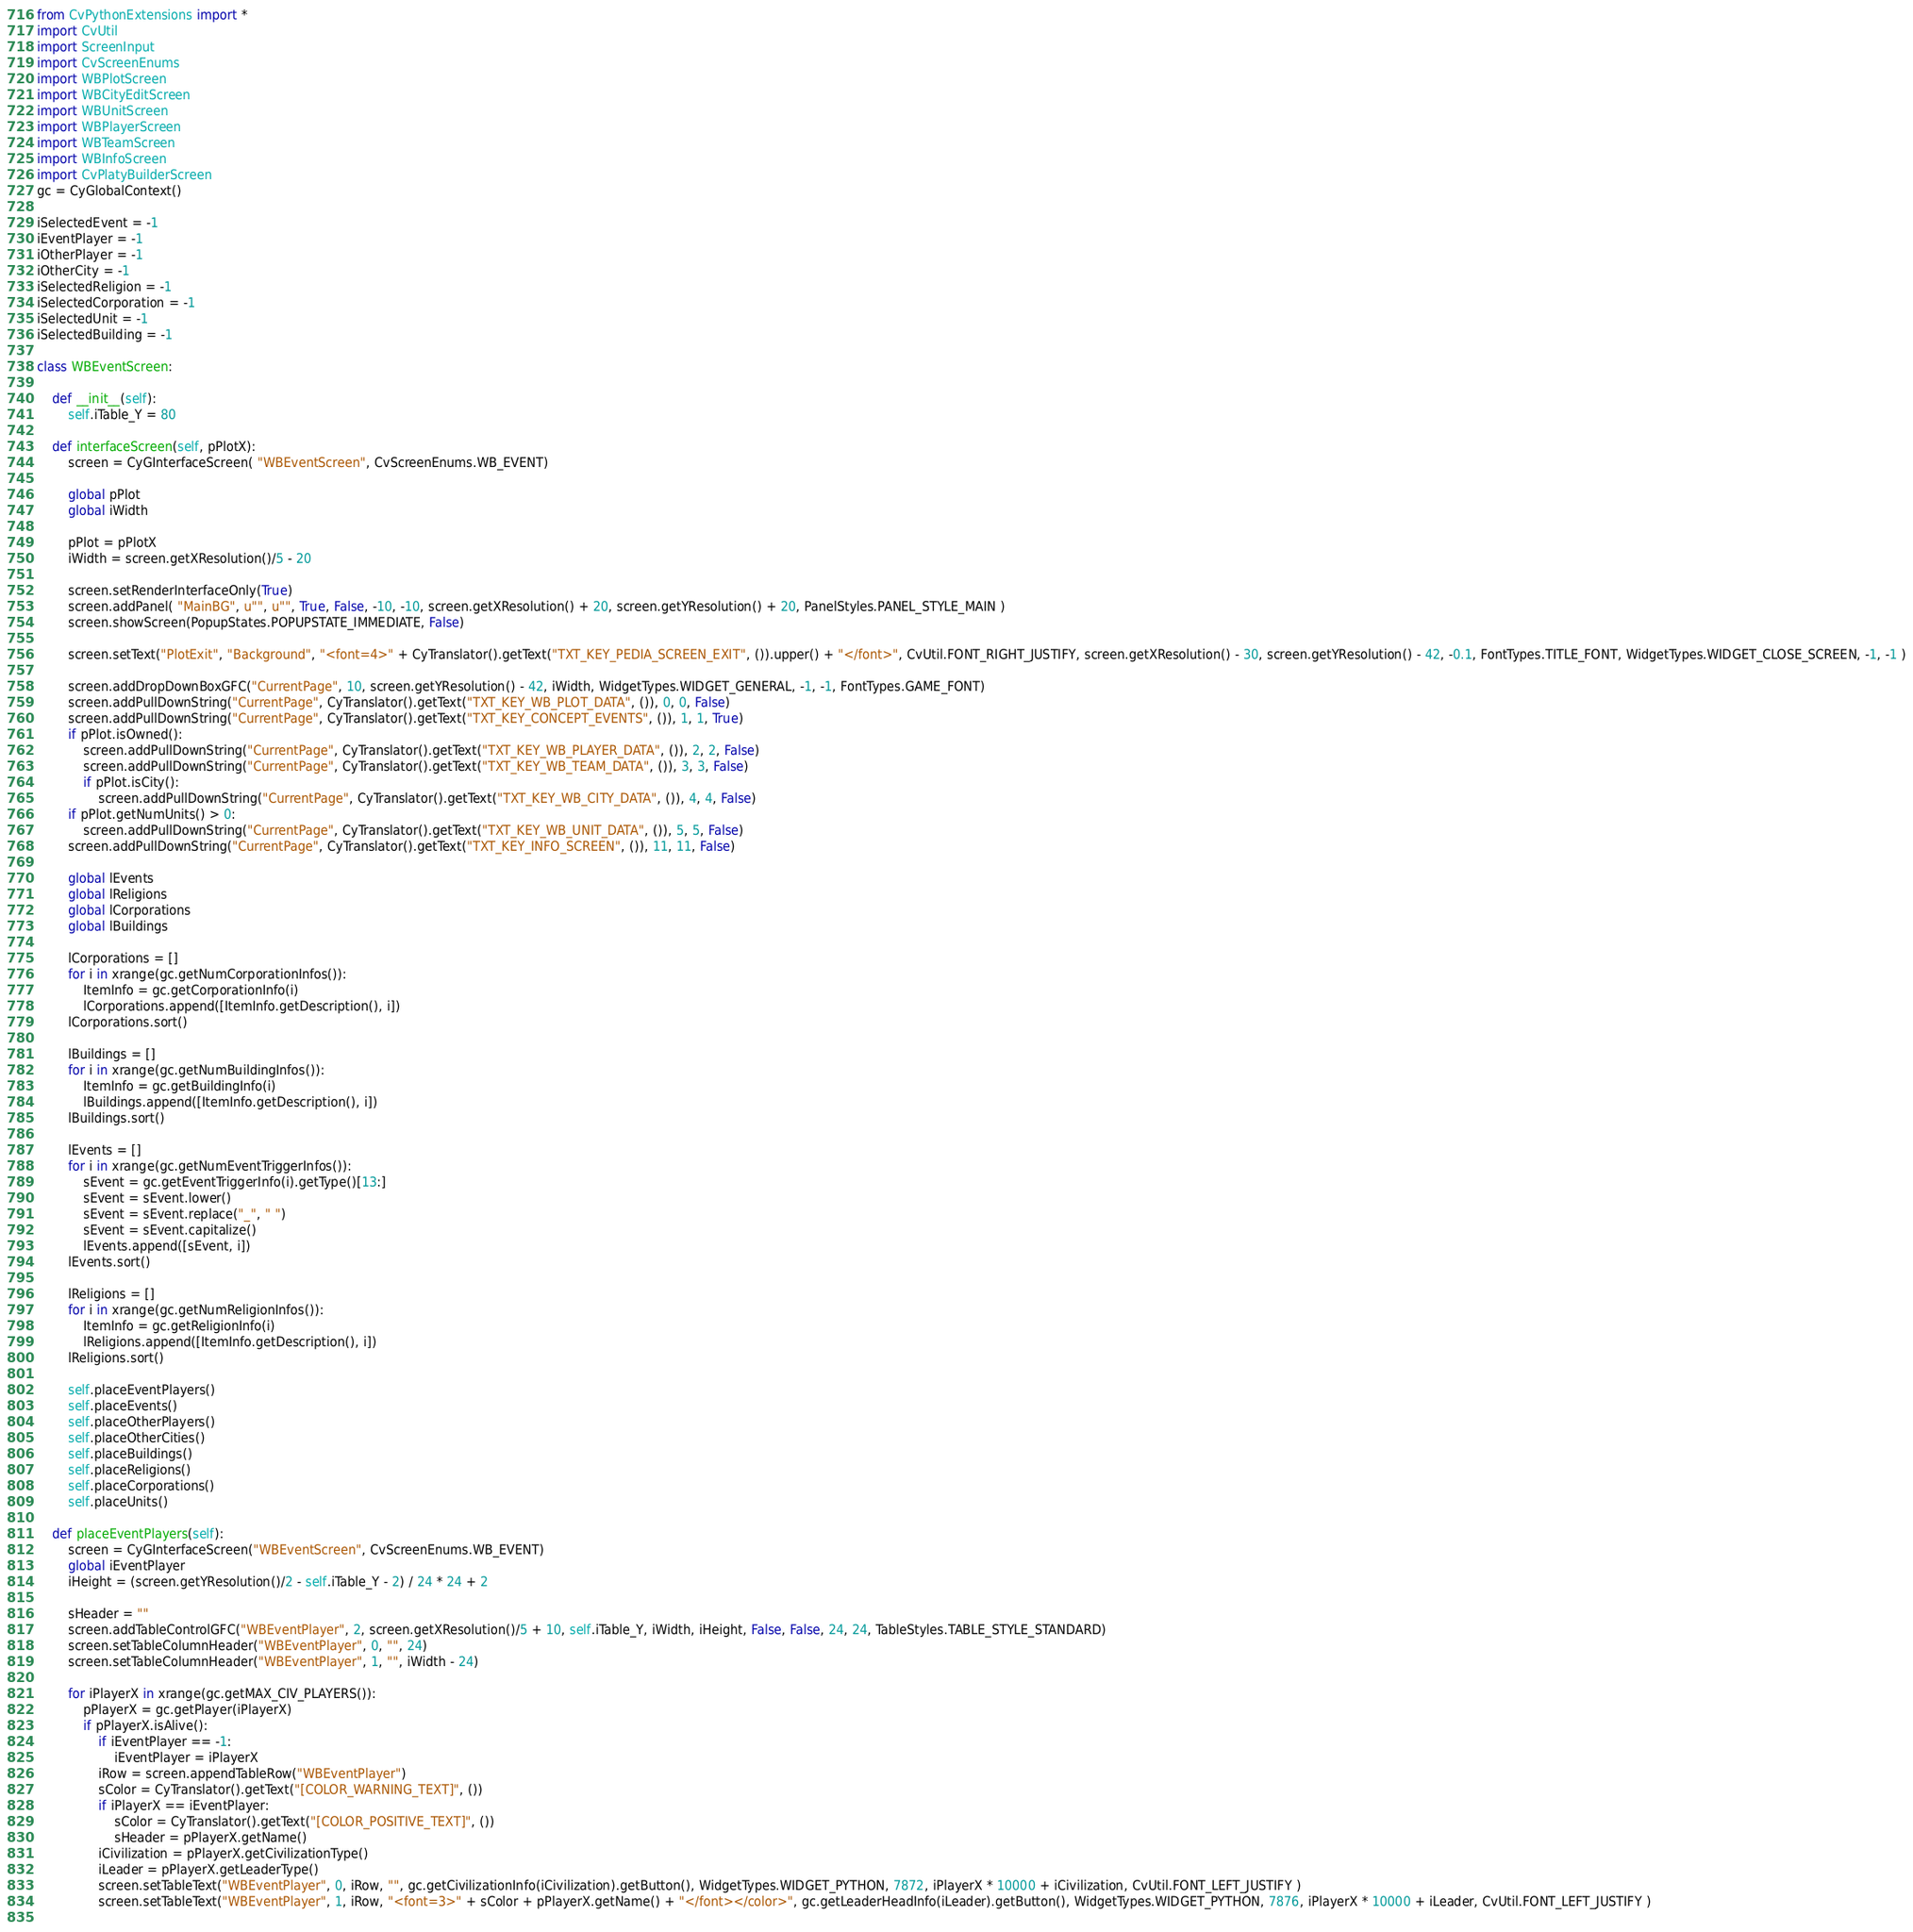Convert code to text. <code><loc_0><loc_0><loc_500><loc_500><_Python_>from CvPythonExtensions import *
import CvUtil
import ScreenInput
import CvScreenEnums
import WBPlotScreen
import WBCityEditScreen
import WBUnitScreen
import WBPlayerScreen
import WBTeamScreen
import WBInfoScreen
import CvPlatyBuilderScreen
gc = CyGlobalContext()

iSelectedEvent = -1
iEventPlayer = -1
iOtherPlayer = -1
iOtherCity = -1
iSelectedReligion = -1
iSelectedCorporation = -1
iSelectedUnit = -1
iSelectedBuilding = -1

class WBEventScreen:

	def __init__(self):
		self.iTable_Y = 80

	def interfaceScreen(self, pPlotX):
		screen = CyGInterfaceScreen( "WBEventScreen", CvScreenEnums.WB_EVENT)
		
		global pPlot
		global iWidth

		pPlot = pPlotX
		iWidth = screen.getXResolution()/5 - 20
		
		screen.setRenderInterfaceOnly(True)
		screen.addPanel( "MainBG", u"", u"", True, False, -10, -10, screen.getXResolution() + 20, screen.getYResolution() + 20, PanelStyles.PANEL_STYLE_MAIN )
		screen.showScreen(PopupStates.POPUPSTATE_IMMEDIATE, False)

		screen.setText("PlotExit", "Background", "<font=4>" + CyTranslator().getText("TXT_KEY_PEDIA_SCREEN_EXIT", ()).upper() + "</font>", CvUtil.FONT_RIGHT_JUSTIFY, screen.getXResolution() - 30, screen.getYResolution() - 42, -0.1, FontTypes.TITLE_FONT, WidgetTypes.WIDGET_CLOSE_SCREEN, -1, -1 )

		screen.addDropDownBoxGFC("CurrentPage", 10, screen.getYResolution() - 42, iWidth, WidgetTypes.WIDGET_GENERAL, -1, -1, FontTypes.GAME_FONT)
		screen.addPullDownString("CurrentPage", CyTranslator().getText("TXT_KEY_WB_PLOT_DATA", ()), 0, 0, False)
		screen.addPullDownString("CurrentPage", CyTranslator().getText("TXT_KEY_CONCEPT_EVENTS", ()), 1, 1, True)
		if pPlot.isOwned():
			screen.addPullDownString("CurrentPage", CyTranslator().getText("TXT_KEY_WB_PLAYER_DATA", ()), 2, 2, False)
			screen.addPullDownString("CurrentPage", CyTranslator().getText("TXT_KEY_WB_TEAM_DATA", ()), 3, 3, False)
			if pPlot.isCity():
				screen.addPullDownString("CurrentPage", CyTranslator().getText("TXT_KEY_WB_CITY_DATA", ()), 4, 4, False)
		if pPlot.getNumUnits() > 0:
			screen.addPullDownString("CurrentPage", CyTranslator().getText("TXT_KEY_WB_UNIT_DATA", ()), 5, 5, False)
		screen.addPullDownString("CurrentPage", CyTranslator().getText("TXT_KEY_INFO_SCREEN", ()), 11, 11, False)

		global lEvents
		global lReligions
		global lCorporations
		global lBuildings

		lCorporations = []
		for i in xrange(gc.getNumCorporationInfos()):
			ItemInfo = gc.getCorporationInfo(i)
			lCorporations.append([ItemInfo.getDescription(), i])
		lCorporations.sort()

		lBuildings = []
		for i in xrange(gc.getNumBuildingInfos()):
			ItemInfo = gc.getBuildingInfo(i)
			lBuildings.append([ItemInfo.getDescription(), i])
		lBuildings.sort()

		lEvents = []
		for i in xrange(gc.getNumEventTriggerInfos()):
			sEvent = gc.getEventTriggerInfo(i).getType()[13:]
			sEvent = sEvent.lower()
			sEvent = sEvent.replace("_", " ")
			sEvent = sEvent.capitalize()
			lEvents.append([sEvent, i])
		lEvents.sort()

		lReligions = []
		for i in xrange(gc.getNumReligionInfos()):
			ItemInfo = gc.getReligionInfo(i)
			lReligions.append([ItemInfo.getDescription(), i])
		lReligions.sort()

		self.placeEventPlayers()
		self.placeEvents()
		self.placeOtherPlayers()
		self.placeOtherCities()
		self.placeBuildings()
		self.placeReligions()
		self.placeCorporations()
		self.placeUnits()

	def placeEventPlayers(self):
		screen = CyGInterfaceScreen("WBEventScreen", CvScreenEnums.WB_EVENT)
		global iEventPlayer
		iHeight = (screen.getYResolution()/2 - self.iTable_Y - 2) / 24 * 24 + 2

		sHeader = ""
		screen.addTableControlGFC("WBEventPlayer", 2, screen.getXResolution()/5 + 10, self.iTable_Y, iWidth, iHeight, False, False, 24, 24, TableStyles.TABLE_STYLE_STANDARD)
		screen.setTableColumnHeader("WBEventPlayer", 0, "", 24)
		screen.setTableColumnHeader("WBEventPlayer", 1, "", iWidth - 24)

		for iPlayerX in xrange(gc.getMAX_CIV_PLAYERS()):
			pPlayerX = gc.getPlayer(iPlayerX)
			if pPlayerX.isAlive():
				if iEventPlayer == -1:
					iEventPlayer = iPlayerX
				iRow = screen.appendTableRow("WBEventPlayer")
				sColor = CyTranslator().getText("[COLOR_WARNING_TEXT]", ())
				if iPlayerX == iEventPlayer:
					sColor = CyTranslator().getText("[COLOR_POSITIVE_TEXT]", ())
					sHeader = pPlayerX.getName()
				iCivilization = pPlayerX.getCivilizationType()
				iLeader = pPlayerX.getLeaderType()
				screen.setTableText("WBEventPlayer", 0, iRow, "", gc.getCivilizationInfo(iCivilization).getButton(), WidgetTypes.WIDGET_PYTHON, 7872, iPlayerX * 10000 + iCivilization, CvUtil.FONT_LEFT_JUSTIFY )
				screen.setTableText("WBEventPlayer", 1, iRow, "<font=3>" + sColor + pPlayerX.getName() + "</font></color>", gc.getLeaderHeadInfo(iLeader).getButton(), WidgetTypes.WIDGET_PYTHON, 7876, iPlayerX * 10000 + iLeader, CvUtil.FONT_LEFT_JUSTIFY )
		</code> 